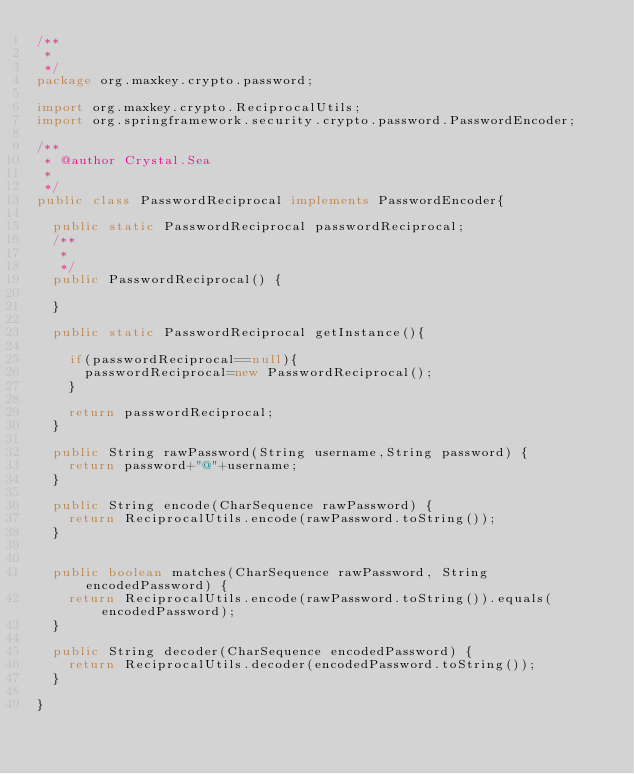<code> <loc_0><loc_0><loc_500><loc_500><_Java_>/**
 * 
 */
package org.maxkey.crypto.password;

import org.maxkey.crypto.ReciprocalUtils;
import org.springframework.security.crypto.password.PasswordEncoder;

/**
 * @author Crystal.Sea
 *
 */
public class PasswordReciprocal implements PasswordEncoder{

	public static PasswordReciprocal passwordReciprocal;
	/**
	 * 
	 */
	public PasswordReciprocal() {
		
	}

	public static PasswordReciprocal getInstance(){
		
		if(passwordReciprocal==null){
			passwordReciprocal=new PasswordReciprocal();
		}
		
		return passwordReciprocal;
	}
	
	public String rawPassword(String username,String password) {
		return password+"@"+username;
	}
	
	public String encode(CharSequence rawPassword) {
		return ReciprocalUtils.encode(rawPassword.toString());
	}


	public boolean matches(CharSequence rawPassword, String encodedPassword) {
		return ReciprocalUtils.encode(rawPassword.toString()).equals(encodedPassword);
	}
	
	public String decoder(CharSequence encodedPassword) {
		return ReciprocalUtils.decoder(encodedPassword.toString());
	}

}
</code> 